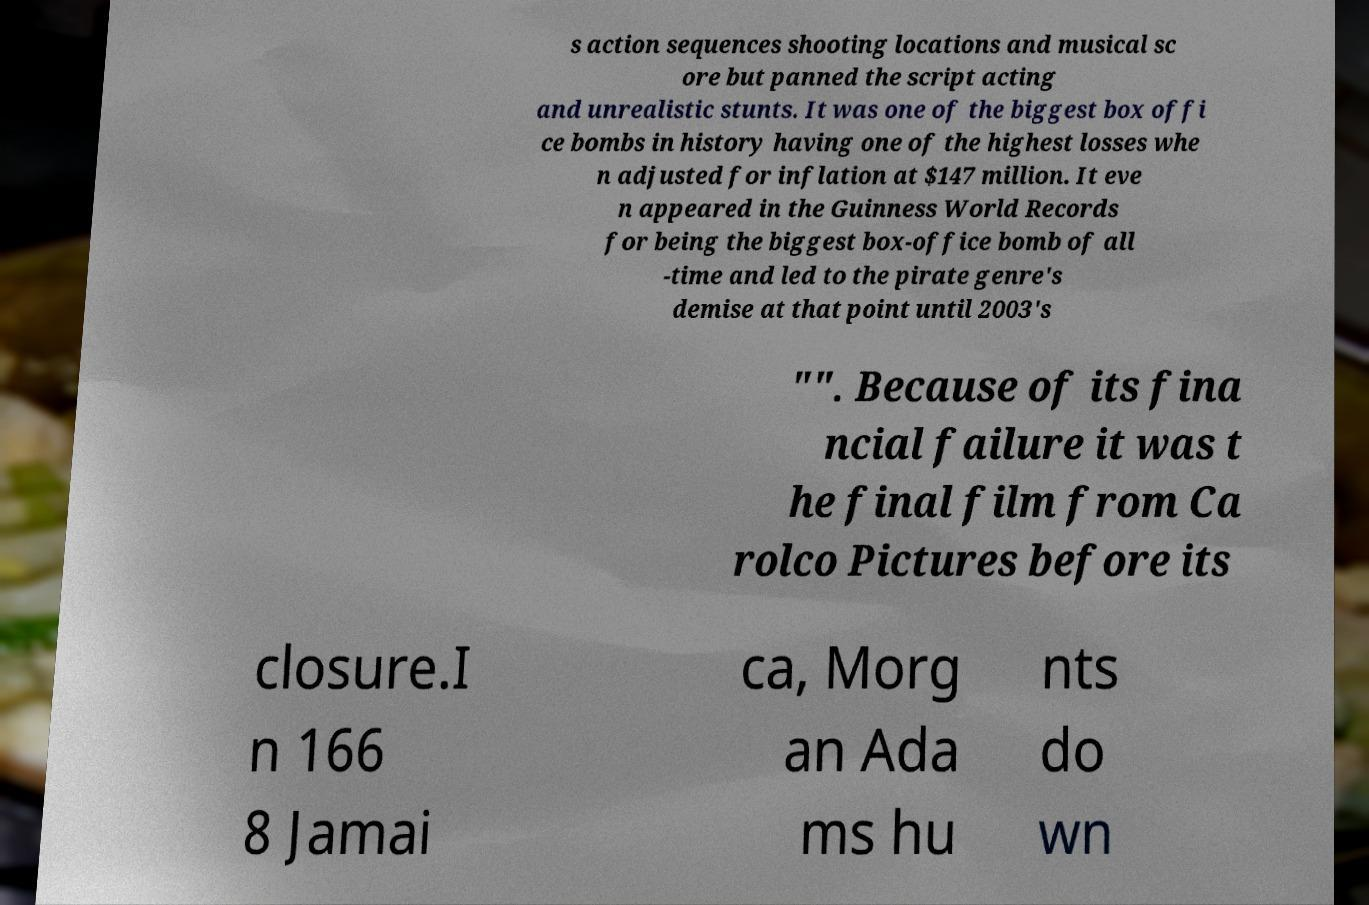Could you assist in decoding the text presented in this image and type it out clearly? s action sequences shooting locations and musical sc ore but panned the script acting and unrealistic stunts. It was one of the biggest box offi ce bombs in history having one of the highest losses whe n adjusted for inflation at $147 million. It eve n appeared in the Guinness World Records for being the biggest box-office bomb of all -time and led to the pirate genre's demise at that point until 2003's "". Because of its fina ncial failure it was t he final film from Ca rolco Pictures before its closure.I n 166 8 Jamai ca, Morg an Ada ms hu nts do wn 